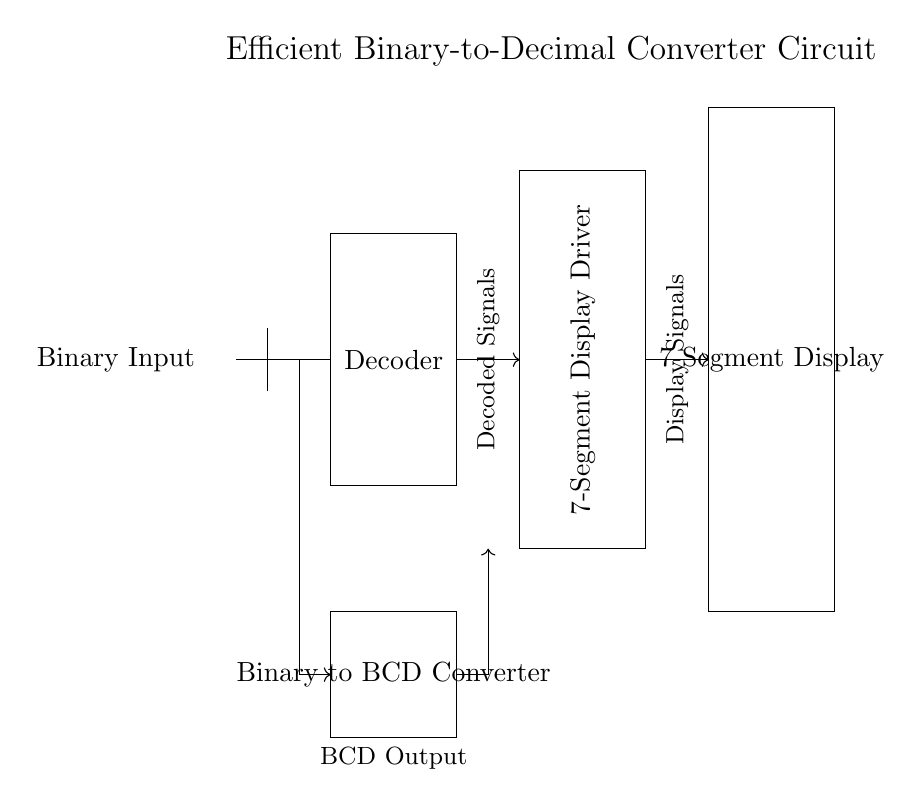What is the main function of the Decoder? The Decoder converts the binary input signals into corresponding decoded signal outputs for further processing.
Answer: Converts binary input What does the Binary to BCD Converter do? The Binary to BCD Converter transforms the binary input into a BCD (Binary-Coded Decimal) output format, enabling easier representation on a display.
Answer: Converts binary to BCD How many segments does the 7-Segment Display have? The 7-Segment Display is composed of seven distinct segments that illuminate to represent decimal digits.
Answer: Seven segments Which component sends signals to the 7-Segment Display? The 7-Segment Display Driver sends the display signals to the 7-Segment Display for visual output.
Answer: Display Driver What is the output format of the Binary to BCD Converter? The output format is BCD, which stands for Binary-Coded Decimal, allowing decimal representation in binary form.
Answer: BCD What type of circuit is presented in this diagram? The circuit is a digital circuit, specifically designed for converting binary numbers to decimal format for data processing applications.
Answer: Digital circuit How does the Binary Input interact with the circuit? The Binary Input provides the initial binary signal, which is processed by the Binary to BCD Converter before being sent to the Decoder and the Driver.
Answer: It provides binary signals 